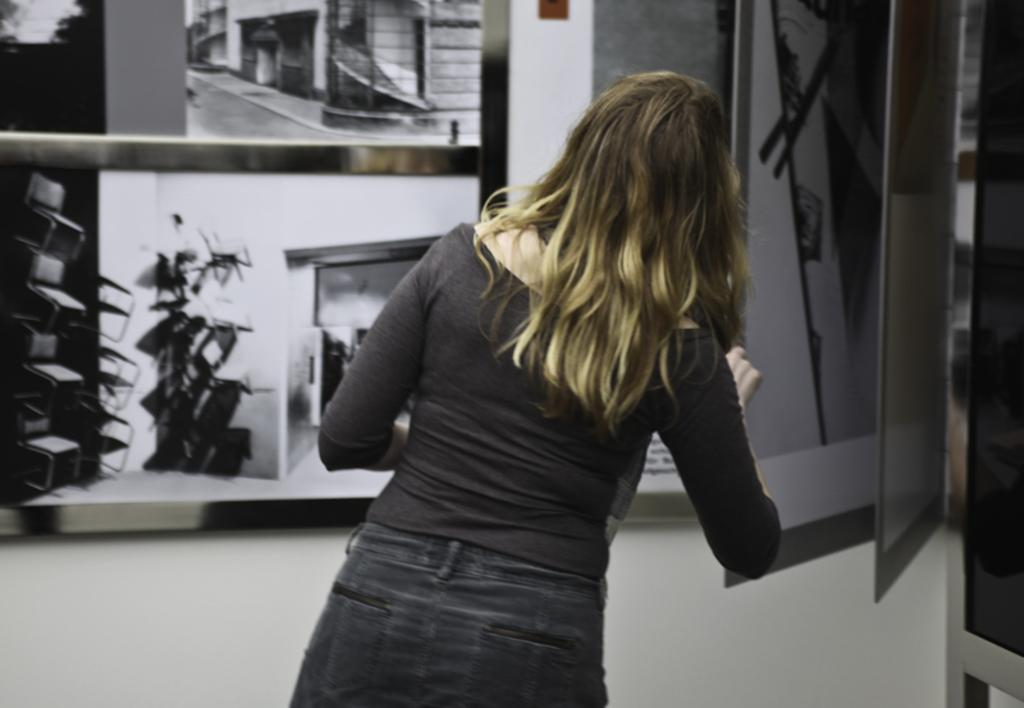Who is the main subject in the image? There is a woman in the image. What is the woman wearing on her upper body? The woman is wearing a black top. What type of pants is the woman wearing? The woman is wearing jeans. What can be seen beneath the woman's feet in the image? There is a floor visible in the image. What type of images are in the background of the image? There are black and white images in the background of the image. What type of dog is sitting next to the woman in the image? There is no dog present in the image; only the woman and the background images are visible. 